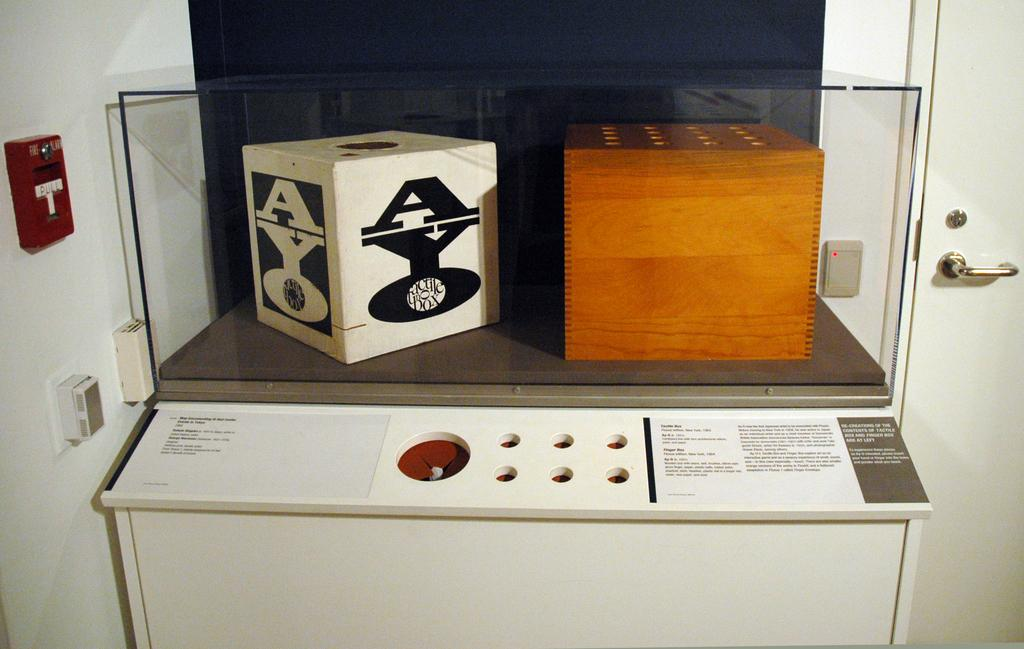<image>
Provide a brief description of the given image. A box with AYO on the side is sitting on a table. 